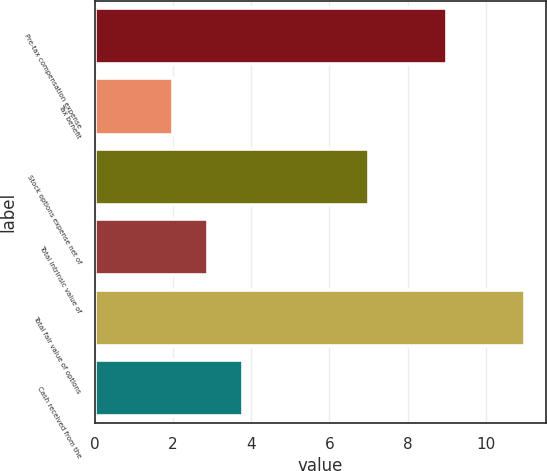Convert chart. <chart><loc_0><loc_0><loc_500><loc_500><bar_chart><fcel>Pre-tax compensation expense<fcel>Tax benefit<fcel>Stock options expense net of<fcel>Total intrinsic value of<fcel>Total fair value of options<fcel>Cash received from the<nl><fcel>9<fcel>2<fcel>7<fcel>2.9<fcel>11<fcel>3.8<nl></chart> 